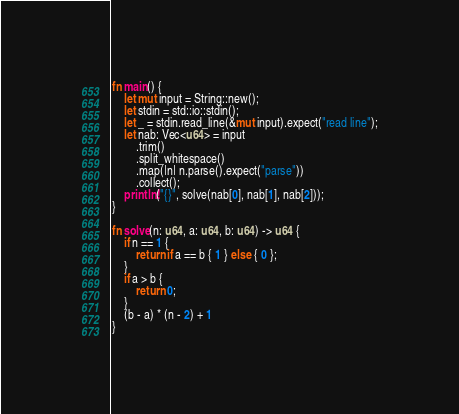<code> <loc_0><loc_0><loc_500><loc_500><_Rust_>fn main() {
    let mut input = String::new();
    let stdin = std::io::stdin();
    let _ = stdin.read_line(&mut input).expect("read line");
    let nab: Vec<u64> = input
        .trim()
        .split_whitespace()
        .map(|n| n.parse().expect("parse"))
        .collect();
    println!("{}", solve(nab[0], nab[1], nab[2]));
}

fn solve(n: u64, a: u64, b: u64) -> u64 {
    if n == 1 {
        return if a == b { 1 } else { 0 };
    }
    if a > b {
        return 0;
    }
    (b - a) * (n - 2) + 1
}
</code> 